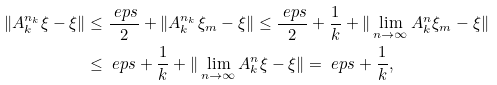Convert formula to latex. <formula><loc_0><loc_0><loc_500><loc_500>\| A _ { k } ^ { n _ { k } } \xi - \xi \| & \leq \frac { \ e p s } { 2 } + \| A ^ { n _ { k } } _ { k } \xi _ { m } - \xi \| \leq \frac { \ e p s } { 2 } + \frac { 1 } { k } + \| \lim _ { n \to \infty } A ^ { n } _ { k } \xi _ { m } - \xi \| \\ & \leq \ e p s + \frac { 1 } { k } + \| \lim _ { n \to \infty } A ^ { n } _ { k } \xi - \xi \| = \ e p s + \frac { 1 } { k } ,</formula> 